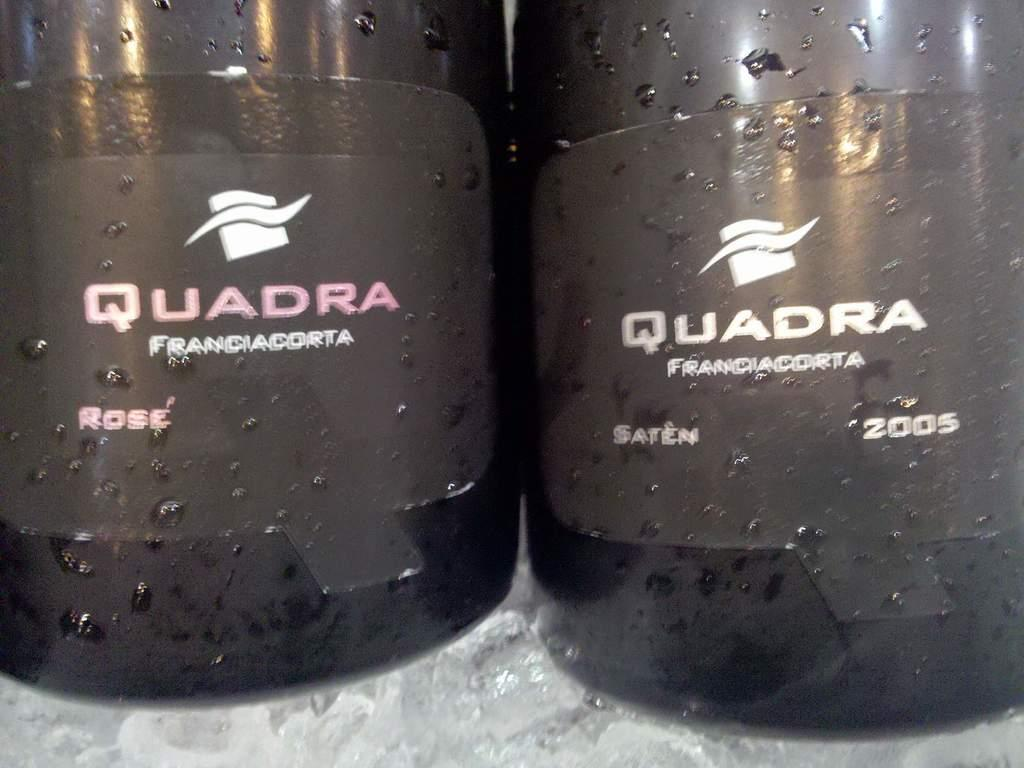<image>
Provide a brief description of the given image. Two bottles of Quadra sit next to each other. 